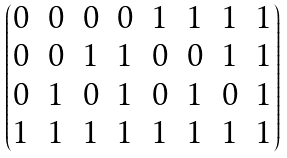Convert formula to latex. <formula><loc_0><loc_0><loc_500><loc_500>\begin{pmatrix} 0 & 0 & 0 & 0 & 1 & 1 & 1 & 1 \\ 0 & 0 & 1 & 1 & 0 & 0 & 1 & 1 \\ 0 & 1 & 0 & 1 & 0 & 1 & 0 & 1 \\ 1 & 1 & 1 & 1 & 1 & 1 & 1 & 1 \end{pmatrix}</formula> 